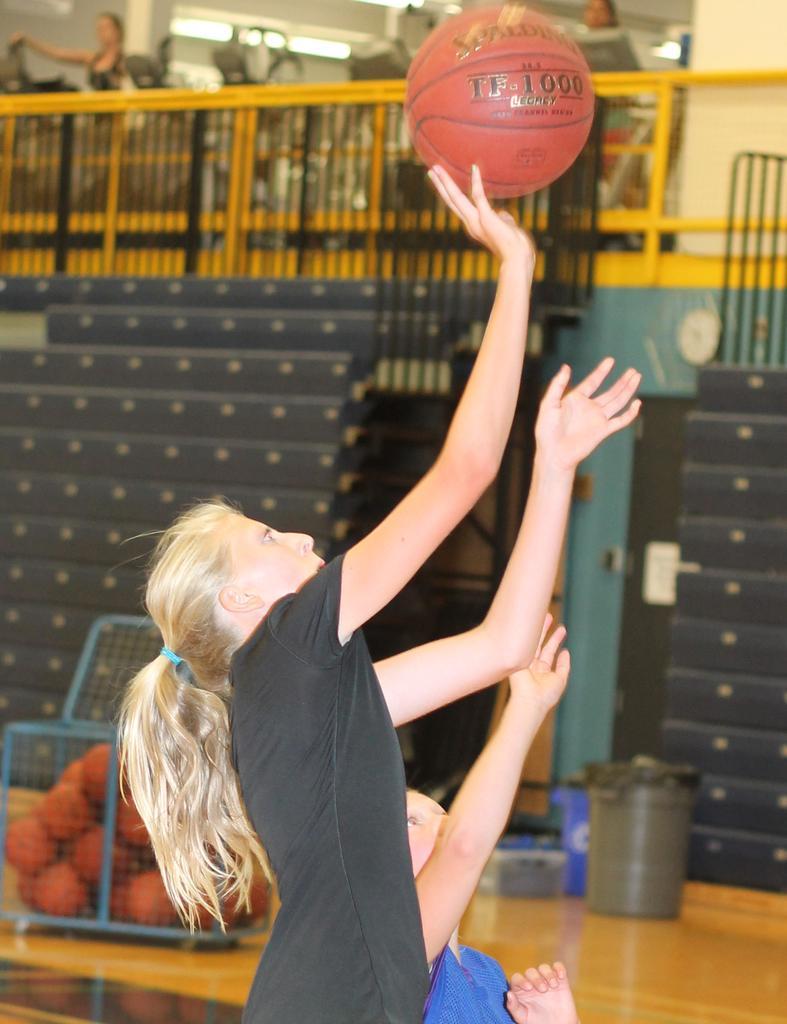Describe this image in one or two sentences. This image is taken in a playing court, where there are two women and a woman in black T shirt is about to throw the ball. In the background, there are balls in the basket, few dustbins, stairs, railing and two persons. 